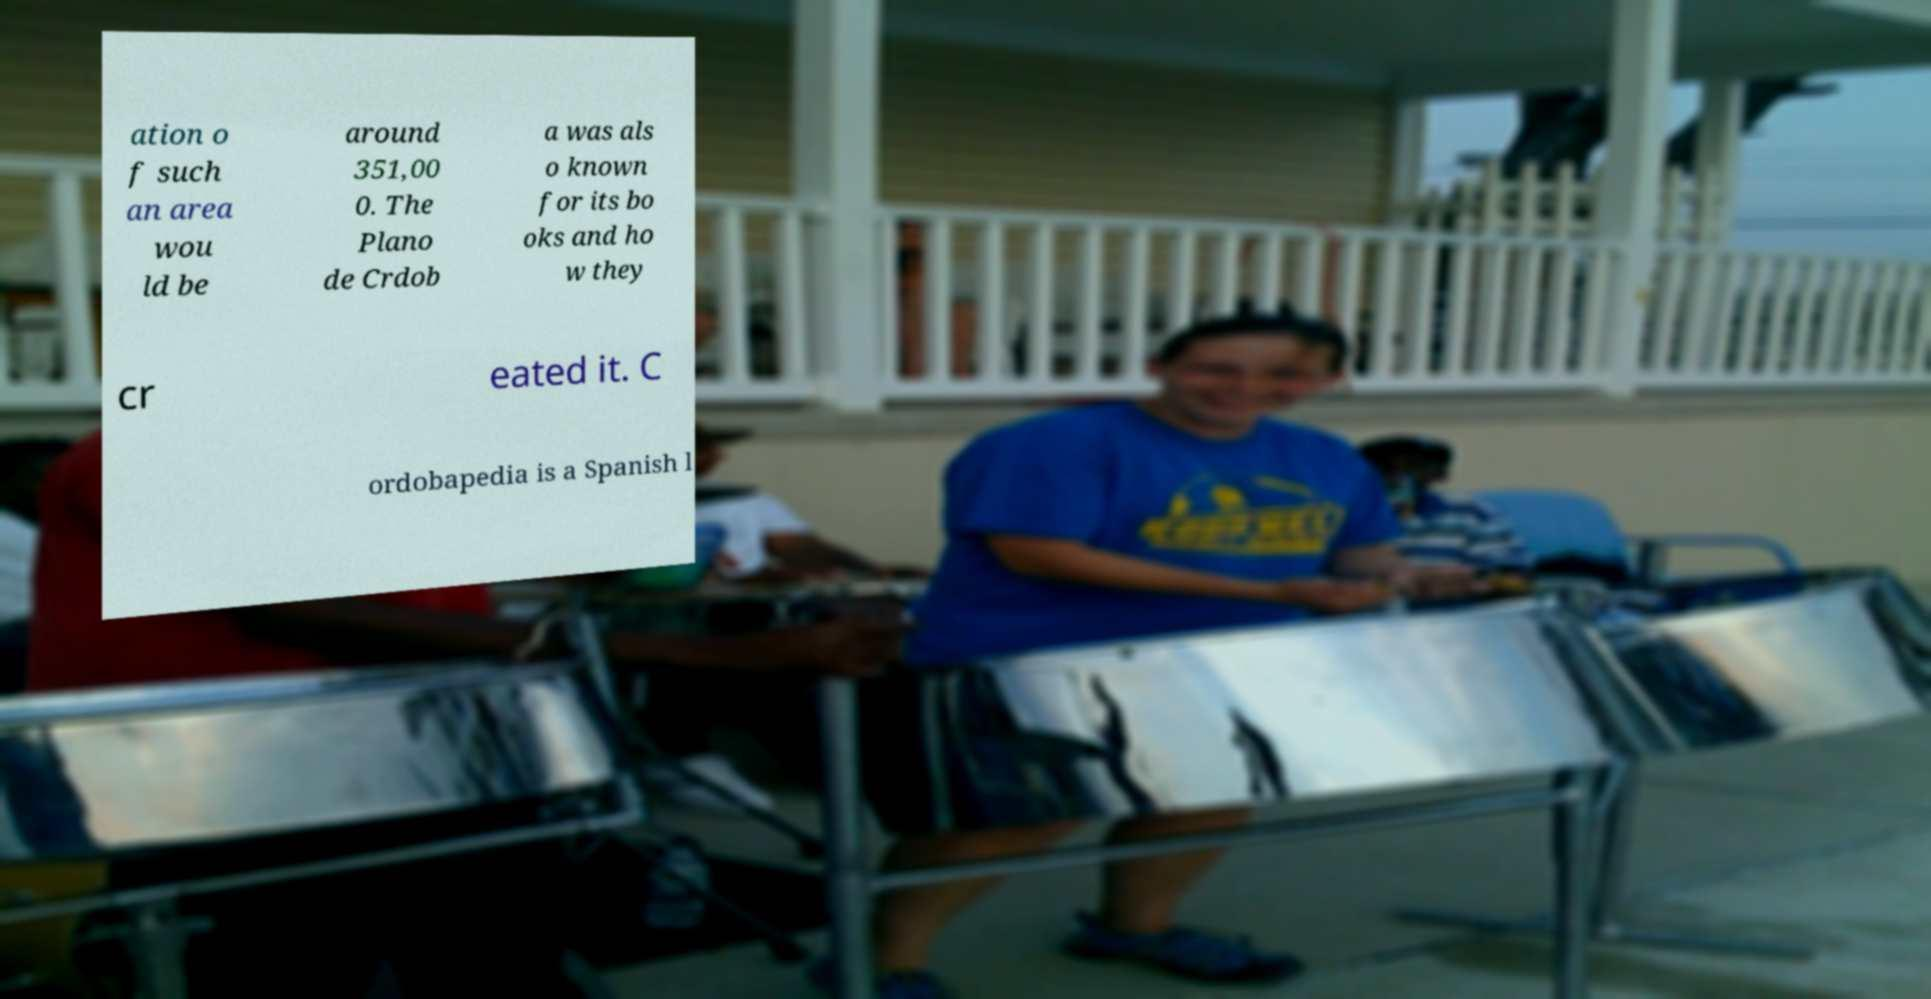Please read and relay the text visible in this image. What does it say? ation o f such an area wou ld be around 351,00 0. The Plano de Crdob a was als o known for its bo oks and ho w they cr eated it. C ordobapedia is a Spanish l 